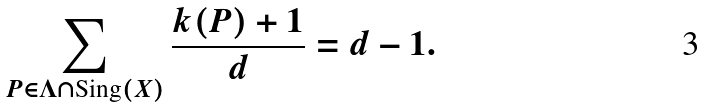<formula> <loc_0><loc_0><loc_500><loc_500>\sum _ { P \in \Lambda \cap \text {Sing} ( X ) } \frac { k ( P ) + 1 } { d } = d - 1 .</formula> 